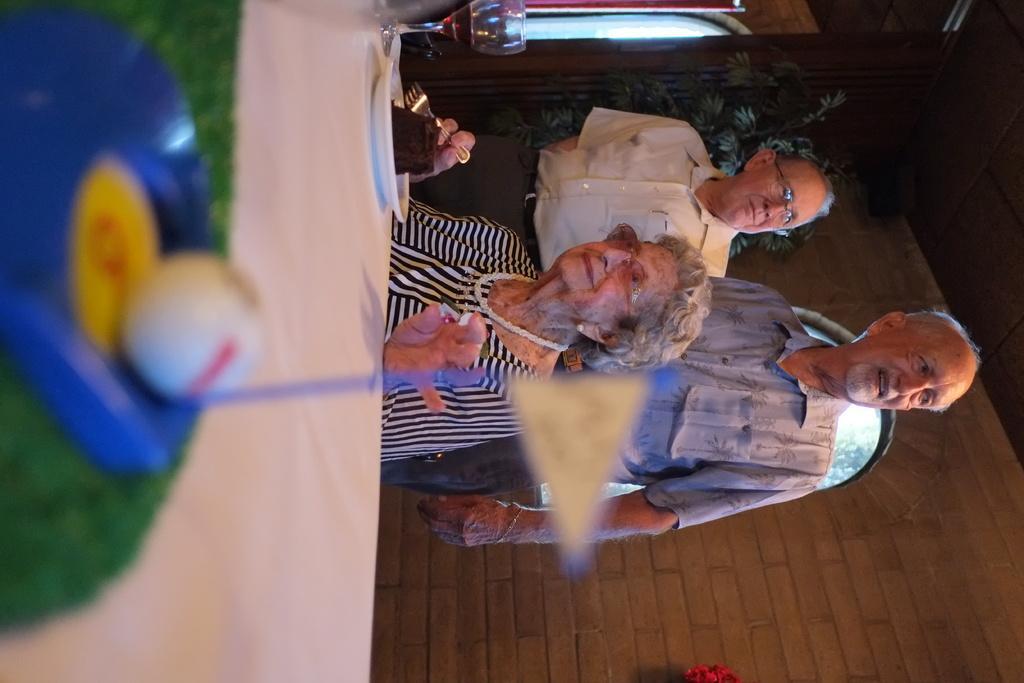In one or two sentences, can you explain what this image depicts? In the center of the image we can see woman sitting at the table. On the table we can see plate, cake, glass and ball. In the background there are two persons, wall, window and tree. 